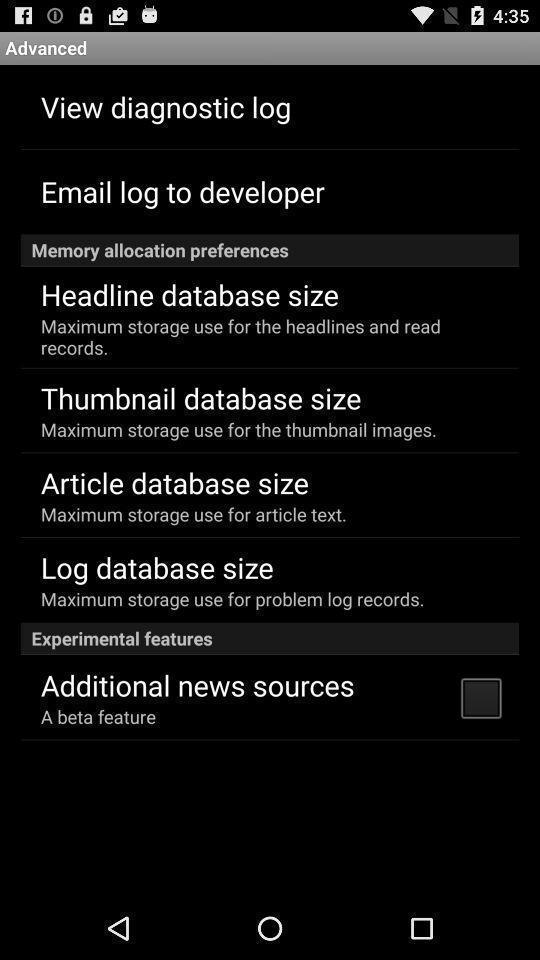Provide a detailed account of this screenshot. Screen displaying multiple storage options in a news application. 